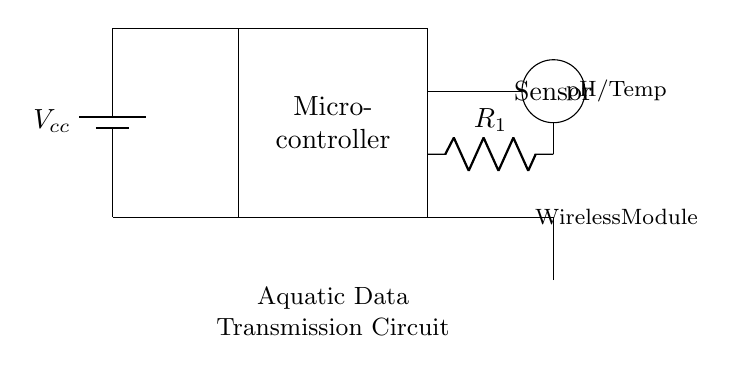What is the main component of the circuit? The main component is the microcontroller, which is the central unit responsible for processing data collected from sensors and controlling other parts of the circuit.
Answer: Microcontroller What does the sensor measure? The sensor measures pH and temperature, as indicated in the diagram. It is represented with a label near it specifying the type of data it collects from the aquatic environment.
Answer: pH/Temp What is the purpose of the antenna? The antenna is used for wireless communication, allowing the circuit to transmit data remotely. This is a key feature for sending data from remote aquatic study sites.
Answer: Wireless communication Which component connects the microcontroller to the sensor? The component connecting the microcontroller to the sensor is the resistor labeled as R1, which helps manage the flow of electrical current between the microcontroller and the sensor.
Answer: R1 What type of circuit is this? This is a wireless data transmission circuit specifically designed for collecting and sending environmental data from remote aquatic study sites. It utilizes a microcontroller, sensor, and antenna for this purpose.
Answer: Aquatic Data Transmission Circuit What is the source of power in this circuit? The power source in this circuit is a battery labeled as Vcc, which provides the necessary voltage for the operation of the circuit components.
Answer: Vcc 